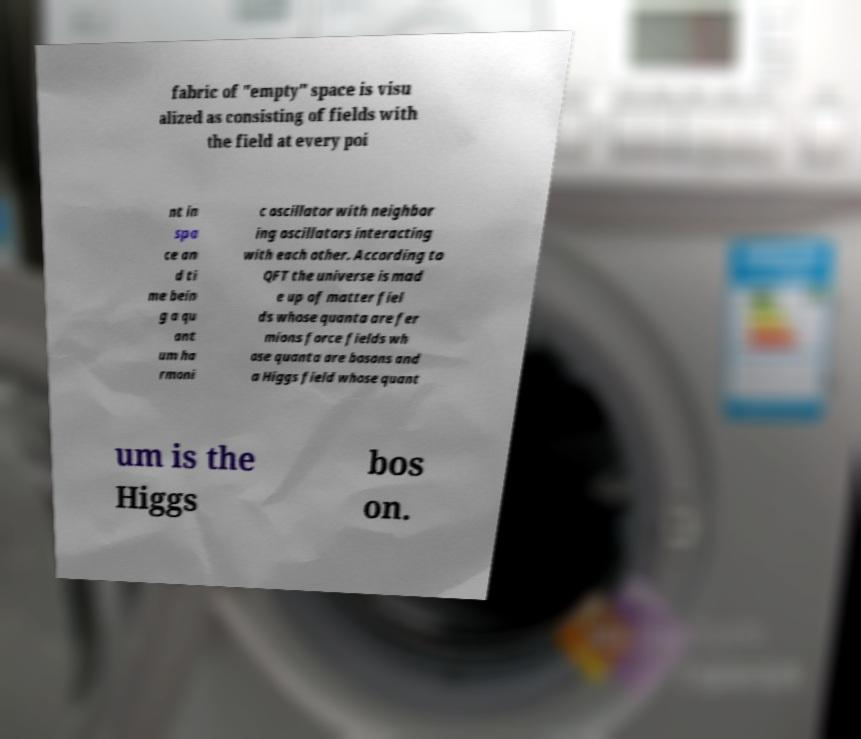Please read and relay the text visible in this image. What does it say? fabric of "empty" space is visu alized as consisting of fields with the field at every poi nt in spa ce an d ti me bein g a qu ant um ha rmoni c oscillator with neighbor ing oscillators interacting with each other. According to QFT the universe is mad e up of matter fiel ds whose quanta are fer mions force fields wh ose quanta are bosons and a Higgs field whose quant um is the Higgs bos on. 